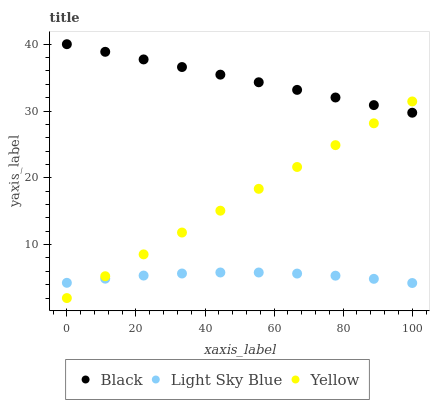Does Light Sky Blue have the minimum area under the curve?
Answer yes or no. Yes. Does Black have the maximum area under the curve?
Answer yes or no. Yes. Does Yellow have the minimum area under the curve?
Answer yes or no. No. Does Yellow have the maximum area under the curve?
Answer yes or no. No. Is Yellow the smoothest?
Answer yes or no. Yes. Is Light Sky Blue the roughest?
Answer yes or no. Yes. Is Black the smoothest?
Answer yes or no. No. Is Black the roughest?
Answer yes or no. No. Does Yellow have the lowest value?
Answer yes or no. Yes. Does Black have the lowest value?
Answer yes or no. No. Does Black have the highest value?
Answer yes or no. Yes. Does Yellow have the highest value?
Answer yes or no. No. Is Light Sky Blue less than Black?
Answer yes or no. Yes. Is Black greater than Light Sky Blue?
Answer yes or no. Yes. Does Black intersect Yellow?
Answer yes or no. Yes. Is Black less than Yellow?
Answer yes or no. No. Is Black greater than Yellow?
Answer yes or no. No. Does Light Sky Blue intersect Black?
Answer yes or no. No. 